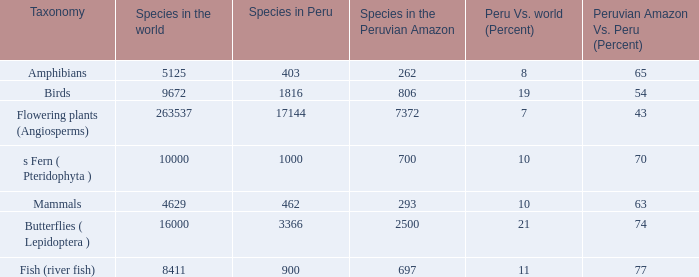What's the total number of species in the peruvian amazon with 8411 species in the world  1.0. 